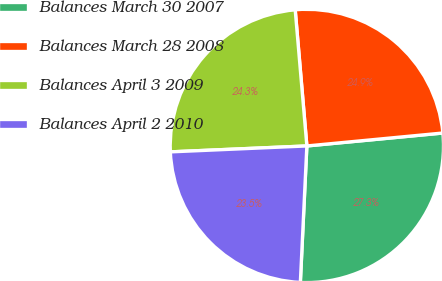Convert chart to OTSL. <chart><loc_0><loc_0><loc_500><loc_500><pie_chart><fcel>Balances March 30 2007<fcel>Balances March 28 2008<fcel>Balances April 3 2009<fcel>Balances April 2 2010<nl><fcel>27.27%<fcel>24.85%<fcel>24.33%<fcel>23.55%<nl></chart> 